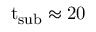<formula> <loc_0><loc_0><loc_500><loc_500>{ t } _ { s u b } \approx 2 0</formula> 